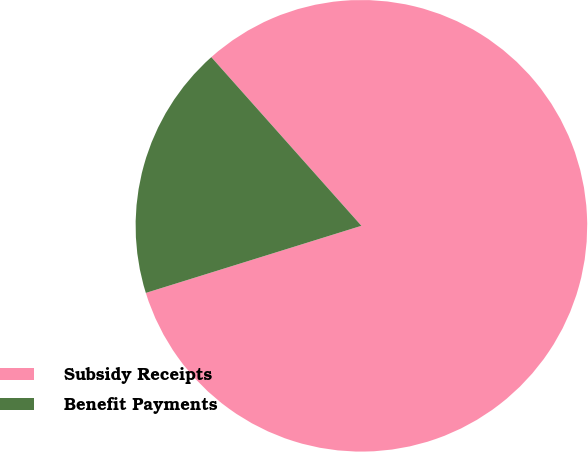Convert chart. <chart><loc_0><loc_0><loc_500><loc_500><pie_chart><fcel>Subsidy Receipts<fcel>Benefit Payments<nl><fcel>81.77%<fcel>18.23%<nl></chart> 